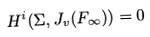Convert formula to latex. <formula><loc_0><loc_0><loc_500><loc_500>H ^ { i } ( \Sigma , J _ { v } ( F _ { \infty } ) ) = 0</formula> 